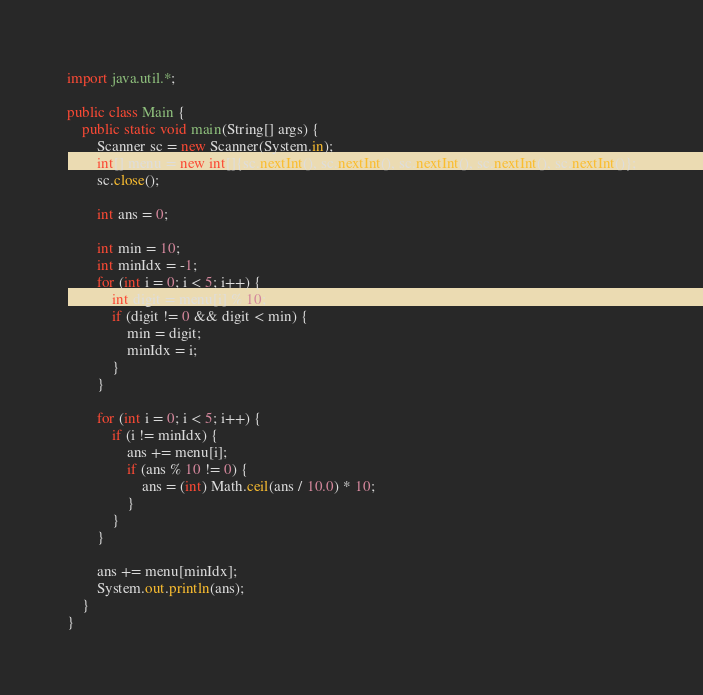Convert code to text. <code><loc_0><loc_0><loc_500><loc_500><_Java_>import java.util.*;

public class Main {
	public static void main(String[] args) {
		Scanner sc = new Scanner(System.in);
		int[] menu = new int[]{sc.nextInt(), sc.nextInt(), sc.nextInt(), sc.nextInt(), sc.nextInt()};
		sc.close();

		int ans = 0;

		int min = 10;
		int minIdx = -1;
		for (int i = 0; i < 5; i++) {
			int digit = menu[i] % 10;
			if (digit != 0 && digit < min) {
				min = digit;
				minIdx = i;
			}
		}

		for (int i = 0; i < 5; i++) {
			if (i != minIdx) {
				ans += menu[i];
				if (ans % 10 != 0) {
					ans = (int) Math.ceil(ans / 10.0) * 10;
				}
			}
		}

		ans += menu[minIdx];
		System.out.println(ans);
	}
}
</code> 